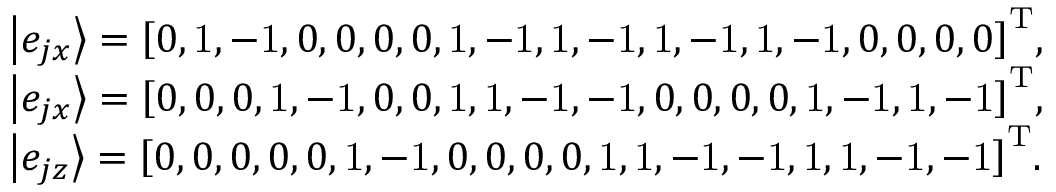<formula> <loc_0><loc_0><loc_500><loc_500>\begin{array} { l } { \left | { { e _ { j x } } } \right \rangle = { \left [ { 0 , { 1 } , - { 1 } 0 0 0 0 , { 1 } , - { 1 } , { 1 } , - { 1 } , { 1 } , - { 1 } , { 1 } , - { 1 } 0 0 0 0 } \right ] ^ { T } } , } \\ { \left | { { e _ { j x } } } \right \rangle = { \left [ { 0 0 0 , { 1 } , - { 1 } 0 0 , { 1 } , { 1 } , - { 1 } , - { 1 } 0 0 0 0 , { 1 } , - { 1 } , { 1 } , - { 1 } } \right ] ^ { T } } , } \\ { \left | { { e _ { j z } } } \right \rangle = { \left [ { 0 0 0 0 0 , { 1 } , - { 1 } 0 0 0 0 , { 1 } , { 1 } , - { 1 } , - { 1 } , { 1 } , { 1 } , - { 1 } , - { 1 } } \right ] ^ { T } } . } \end{array}</formula> 